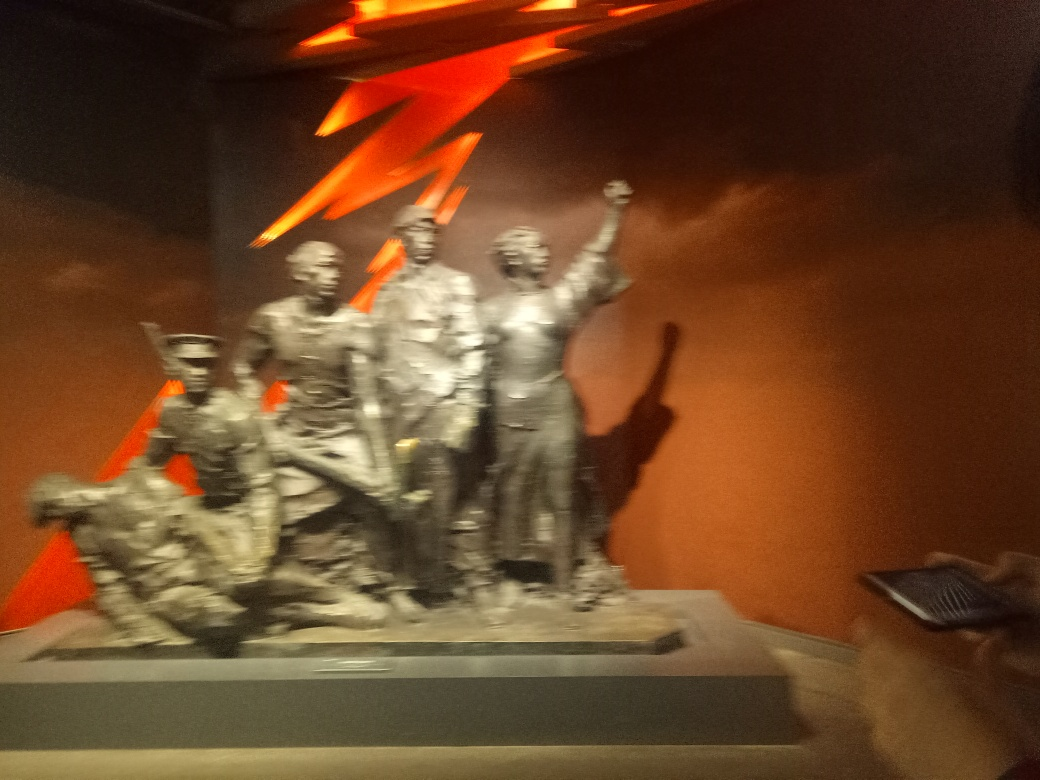What mood does the sculpture convey? Despite the blurriness of the image, there's a palpable sense of dynamism and vigor emanating from the sculpture. The raised fists and assertive stances suggest themes of determination, defiance, or triumph, which are often found in commemorative monuments. 